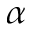<formula> <loc_0><loc_0><loc_500><loc_500>\alpha</formula> 